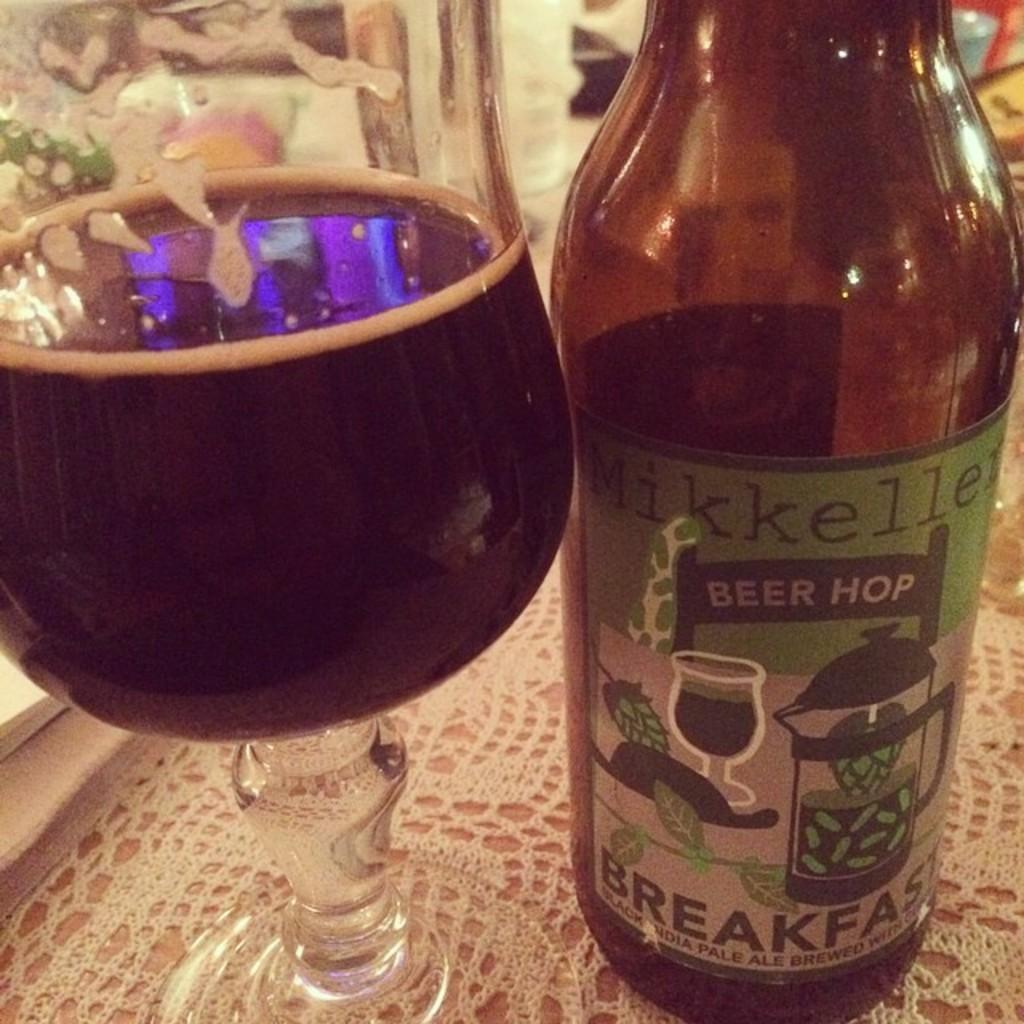<image>
Share a concise interpretation of the image provided. Beer glass half full of Mikkeller Beer Hop sitting next to it. 